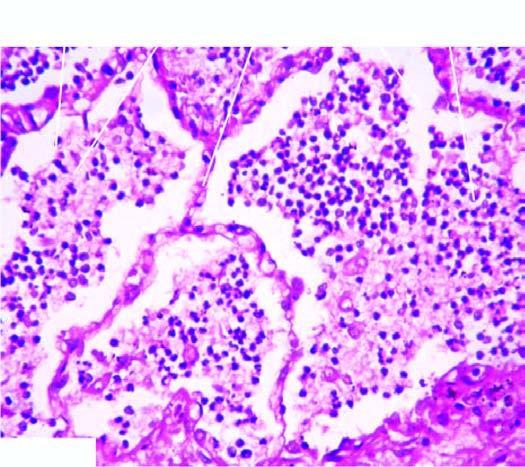what is the cellular exudates in the alveolar lumina lying separated from by a clear space?
Answer the question using a single word or phrase. Septal walls 